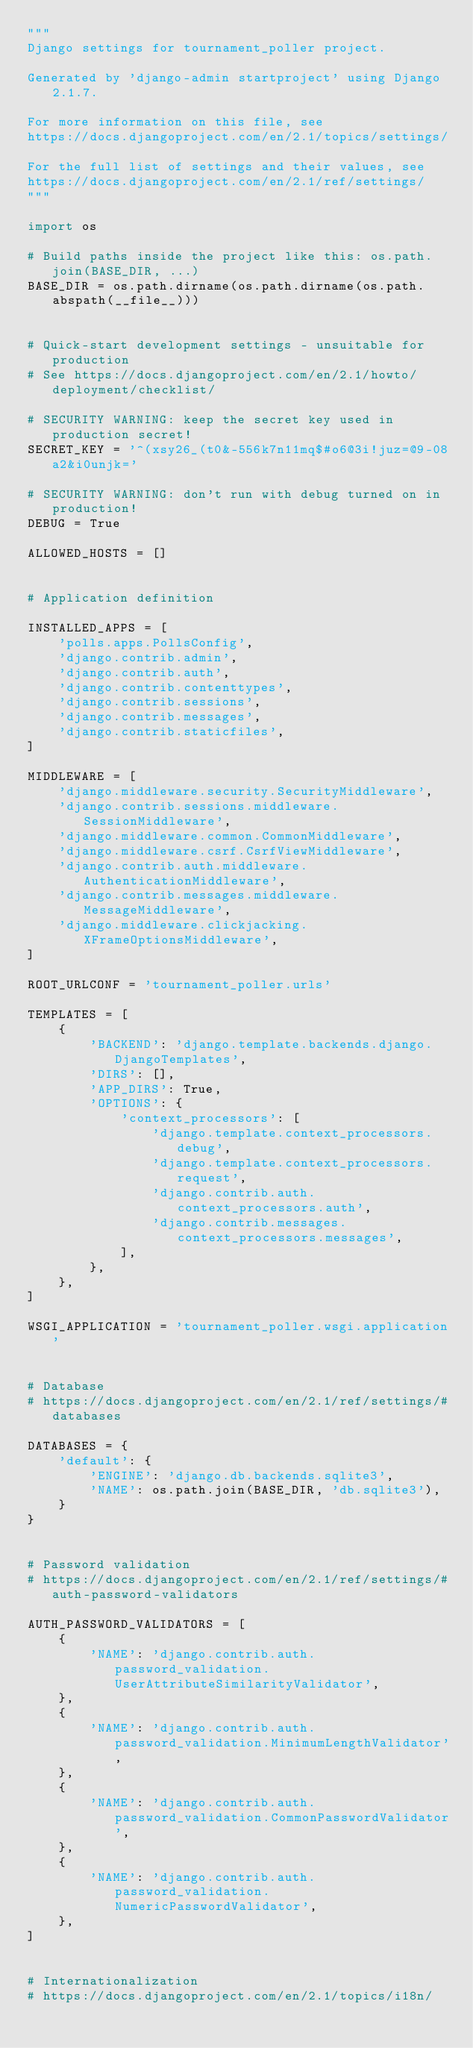Convert code to text. <code><loc_0><loc_0><loc_500><loc_500><_Python_>"""
Django settings for tournament_poller project.

Generated by 'django-admin startproject' using Django 2.1.7.

For more information on this file, see
https://docs.djangoproject.com/en/2.1/topics/settings/

For the full list of settings and their values, see
https://docs.djangoproject.com/en/2.1/ref/settings/
"""

import os

# Build paths inside the project like this: os.path.join(BASE_DIR, ...)
BASE_DIR = os.path.dirname(os.path.dirname(os.path.abspath(__file__)))


# Quick-start development settings - unsuitable for production
# See https://docs.djangoproject.com/en/2.1/howto/deployment/checklist/

# SECURITY WARNING: keep the secret key used in production secret!
SECRET_KEY = '^(xsy26_(t0&-556k7n11mq$#o6@3i!juz=@9-08a2&i0unjk='

# SECURITY WARNING: don't run with debug turned on in production!
DEBUG = True

ALLOWED_HOSTS = []


# Application definition

INSTALLED_APPS = [
    'polls.apps.PollsConfig',
    'django.contrib.admin',
    'django.contrib.auth',
    'django.contrib.contenttypes',
    'django.contrib.sessions',
    'django.contrib.messages',
    'django.contrib.staticfiles',
]

MIDDLEWARE = [
    'django.middleware.security.SecurityMiddleware',
    'django.contrib.sessions.middleware.SessionMiddleware',
    'django.middleware.common.CommonMiddleware',
    'django.middleware.csrf.CsrfViewMiddleware',
    'django.contrib.auth.middleware.AuthenticationMiddleware',
    'django.contrib.messages.middleware.MessageMiddleware',
    'django.middleware.clickjacking.XFrameOptionsMiddleware',
]

ROOT_URLCONF = 'tournament_poller.urls'

TEMPLATES = [
    {
        'BACKEND': 'django.template.backends.django.DjangoTemplates',
        'DIRS': [],
        'APP_DIRS': True,
        'OPTIONS': {
            'context_processors': [
                'django.template.context_processors.debug',
                'django.template.context_processors.request',
                'django.contrib.auth.context_processors.auth',
                'django.contrib.messages.context_processors.messages',
            ],
        },
    },
]

WSGI_APPLICATION = 'tournament_poller.wsgi.application'


# Database
# https://docs.djangoproject.com/en/2.1/ref/settings/#databases

DATABASES = {
    'default': {
        'ENGINE': 'django.db.backends.sqlite3',
        'NAME': os.path.join(BASE_DIR, 'db.sqlite3'),
    }
}


# Password validation
# https://docs.djangoproject.com/en/2.1/ref/settings/#auth-password-validators

AUTH_PASSWORD_VALIDATORS = [
    {
        'NAME': 'django.contrib.auth.password_validation.UserAttributeSimilarityValidator',
    },
    {
        'NAME': 'django.contrib.auth.password_validation.MinimumLengthValidator',
    },
    {
        'NAME': 'django.contrib.auth.password_validation.CommonPasswordValidator',
    },
    {
        'NAME': 'django.contrib.auth.password_validation.NumericPasswordValidator',
    },
]


# Internationalization
# https://docs.djangoproject.com/en/2.1/topics/i18n/
</code> 